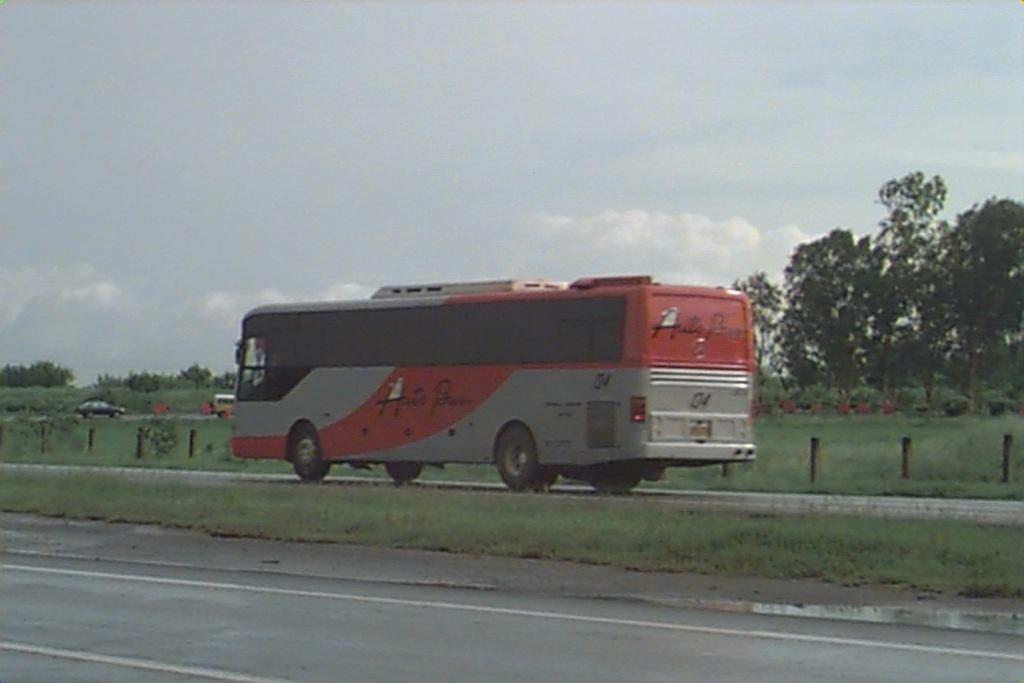What types of objects are present in the image? There are vehicles in the image. What kind of barrier can be seen in the image? There is fencing in the image. What type of vegetation is visible in the image? There are trees in the image. What is the color of the grass in the image? The grass in the image is green. How would you describe the color of the sky in the image? The sky is a combination of white and blue colors. How many stamps are on the vehicles in the image? There are no stamps present on the vehicles in the image; it is a photograph of vehicles, fencing, trees, grass, and the sky. 